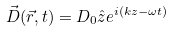<formula> <loc_0><loc_0><loc_500><loc_500>\vec { D } ( \vec { r } , t ) = D _ { 0 } \hat { z } e ^ { i ( k z - \omega t ) }</formula> 